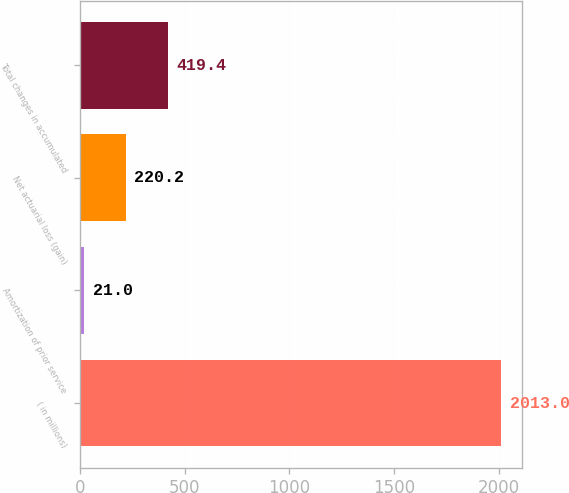Convert chart. <chart><loc_0><loc_0><loc_500><loc_500><bar_chart><fcel>( in millions)<fcel>Amortization of prior service<fcel>Net actuarial loss (gain)<fcel>Total changes in accumulated<nl><fcel>2013<fcel>21<fcel>220.2<fcel>419.4<nl></chart> 